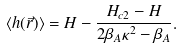<formula> <loc_0><loc_0><loc_500><loc_500>\langle h ( \vec { r } ) \rangle = H - \frac { H _ { c 2 } - H } { 2 \beta _ { A } \kappa ^ { 2 } - \beta _ { A } } .</formula> 